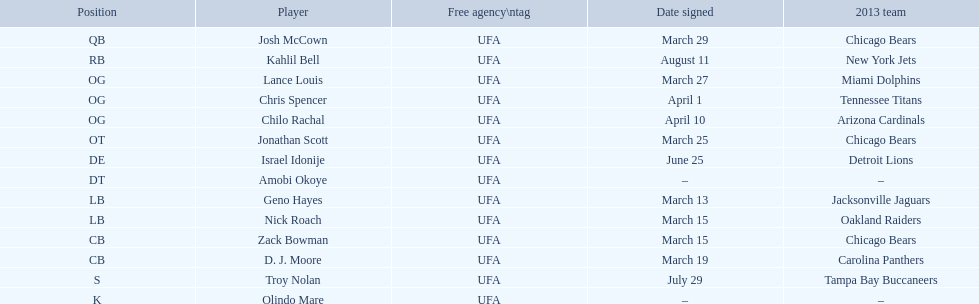What are all the dates with signatures? March 29, August 11, March 27, April 1, April 10, March 25, June 25, March 13, March 15, March 15, March 19, July 29. Which among these are duplicates? March 15, March 15. Who possesses the same one as nick roach? Zack Bowman. 